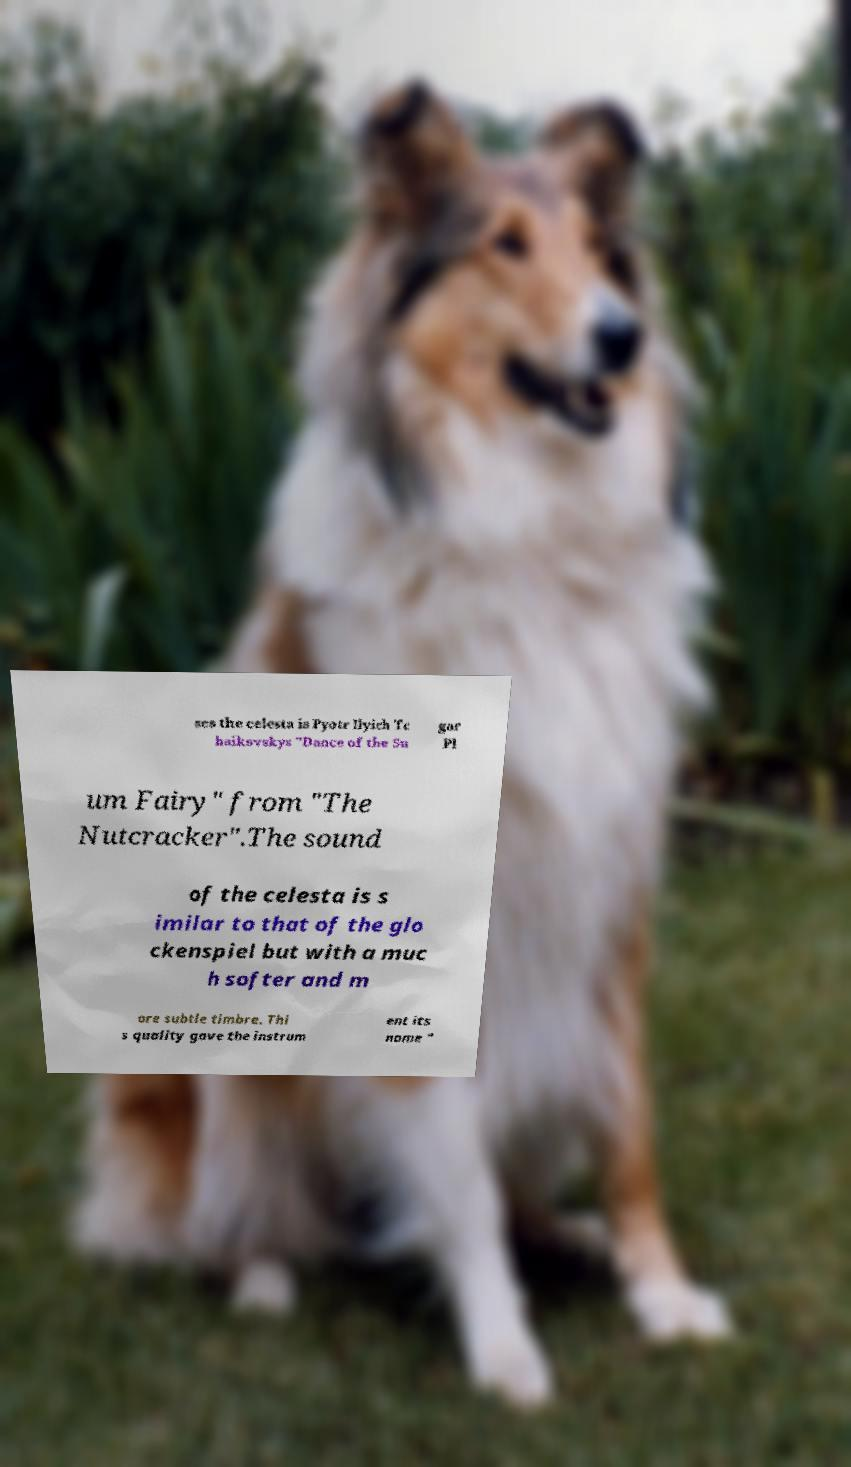Please read and relay the text visible in this image. What does it say? ses the celesta is Pyotr Ilyich Tc haikovskys "Dance of the Su gar Pl um Fairy" from "The Nutcracker".The sound of the celesta is s imilar to that of the glo ckenspiel but with a muc h softer and m ore subtle timbre. Thi s quality gave the instrum ent its name " 